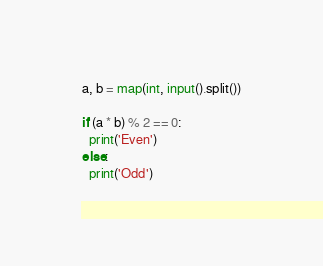<code> <loc_0><loc_0><loc_500><loc_500><_Python_>a, b = map(int, input().split())

if (a * b) % 2 == 0:
  print('Even')
else:
  print('Odd')
</code> 